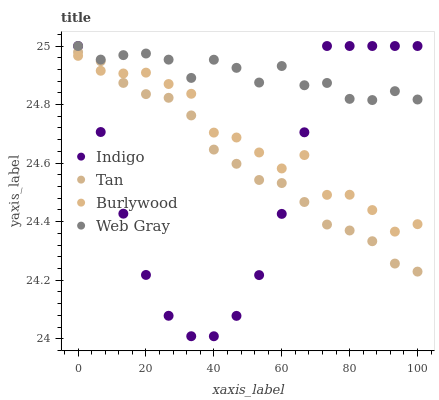Does Indigo have the minimum area under the curve?
Answer yes or no. Yes. Does Web Gray have the maximum area under the curve?
Answer yes or no. Yes. Does Tan have the minimum area under the curve?
Answer yes or no. No. Does Tan have the maximum area under the curve?
Answer yes or no. No. Is Tan the smoothest?
Answer yes or no. Yes. Is Burlywood the roughest?
Answer yes or no. Yes. Is Web Gray the smoothest?
Answer yes or no. No. Is Web Gray the roughest?
Answer yes or no. No. Does Indigo have the lowest value?
Answer yes or no. Yes. Does Tan have the lowest value?
Answer yes or no. No. Does Indigo have the highest value?
Answer yes or no. Yes. Does Tan have the highest value?
Answer yes or no. No. Is Tan less than Web Gray?
Answer yes or no. Yes. Is Web Gray greater than Tan?
Answer yes or no. Yes. Does Indigo intersect Web Gray?
Answer yes or no. Yes. Is Indigo less than Web Gray?
Answer yes or no. No. Is Indigo greater than Web Gray?
Answer yes or no. No. Does Tan intersect Web Gray?
Answer yes or no. No. 